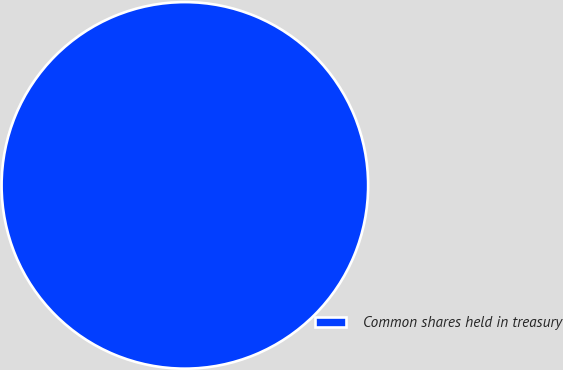Convert chart. <chart><loc_0><loc_0><loc_500><loc_500><pie_chart><fcel>Common shares held in treasury<nl><fcel>100.0%<nl></chart> 